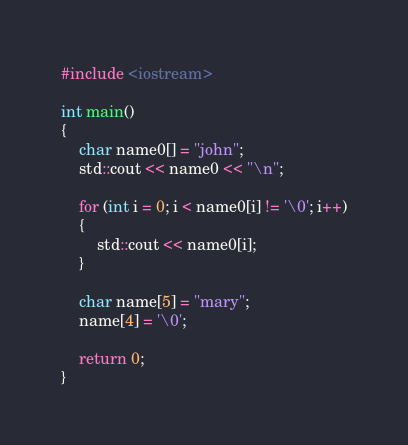<code> <loc_0><loc_0><loc_500><loc_500><_C++_>#include <iostream>

int main()
{
	char name0[] = "john";
	std::cout << name0 << "\n";

	for (int i = 0; i < name0[i] != '\0'; i++)
	{
		std::cout << name0[i];
	}

	char name[5] = "mary";
	name[4] = '\0';

	return 0;
}</code> 